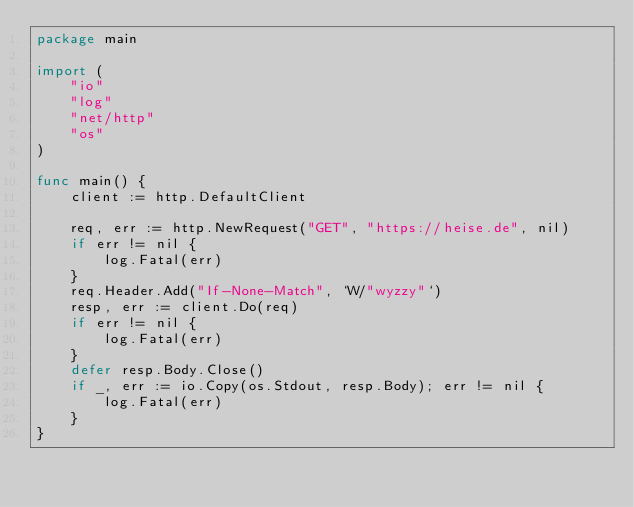<code> <loc_0><loc_0><loc_500><loc_500><_Go_>package main

import (
	"io"
	"log"
	"net/http"
	"os"
)

func main() {
	client := http.DefaultClient

	req, err := http.NewRequest("GET", "https://heise.de", nil)
	if err != nil {
		log.Fatal(err)
	}
	req.Header.Add("If-None-Match", `W/"wyzzy"`)
	resp, err := client.Do(req)
	if err != nil {
		log.Fatal(err)
	}
	defer resp.Body.Close()
	if _, err := io.Copy(os.Stdout, resp.Body); err != nil {
		log.Fatal(err)
	}
}
</code> 